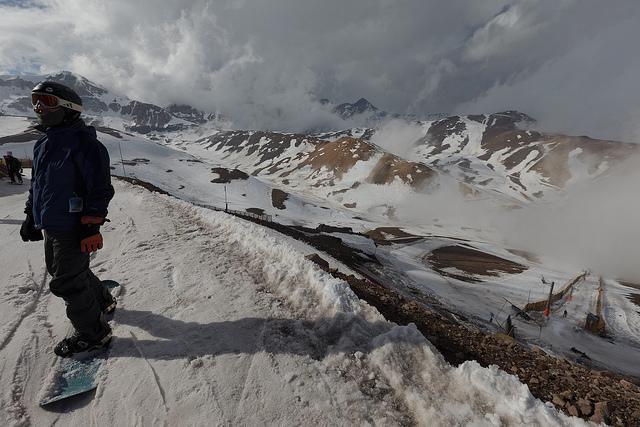How many snowboarders are shown?
Give a very brief answer. 1. How many snowboards are in the photo?
Give a very brief answer. 1. How many zebras are in the picture?
Give a very brief answer. 0. 